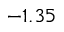Convert formula to latex. <formula><loc_0><loc_0><loc_500><loc_500>- 1 . 3 5</formula> 